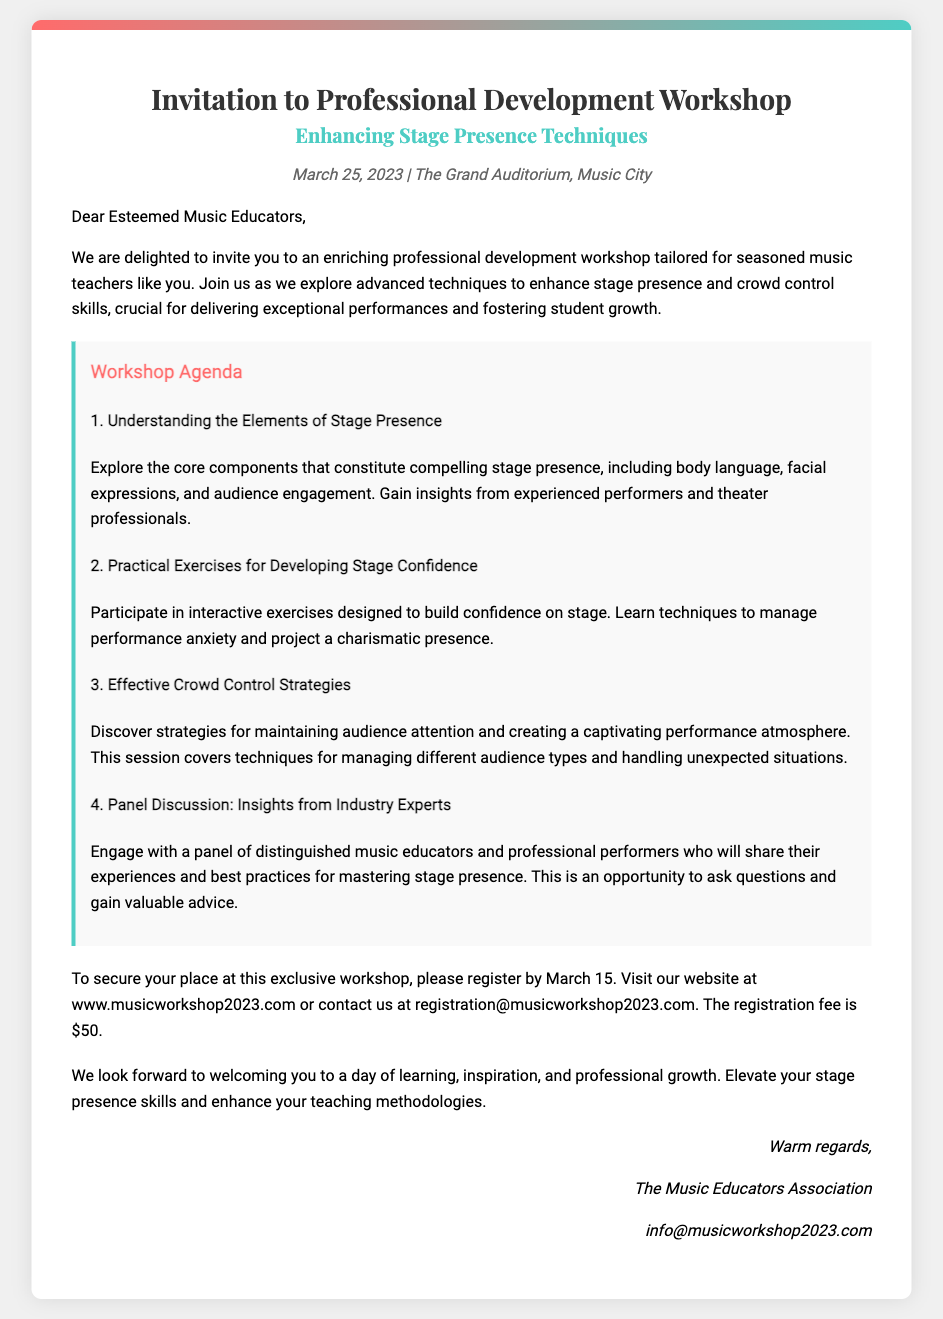what is the title of the workshop? The title of the workshop is mentioned prominently at the beginning of the document.
Answer: Enhancing Stage Presence Techniques when is the workshop taking place? The date of the workshop is specified in the header information section.
Answer: March 25, 2023 where is the workshop held? The location of the workshop is provided in the header information section.
Answer: The Grand Auditorium, Music City what is the registration deadline? The registration deadline is clearly stated in the registration section of the document.
Answer: March 15 how much is the registration fee? The registration fee is indicated in the registration section of the document.
Answer: $50 what is one of the topics covered in the workshop agenda? The workshop agenda lists multiple topics, and one can be chosen for this question.
Answer: Understanding the Elements of Stage Presence who should attend the workshop? The document specifically addresses whom the workshop is tailored for in the opening paragraph.
Answer: Seasoned music teachers what is the contact email for registration? The email contact for registration is provided in the closing section of the document.
Answer: registration@musicworkshop2023.com what type of professionals will engage in the panel discussion? The panel discussion features a specific group of professionals highlighted in the agenda.
Answer: Industry Experts 